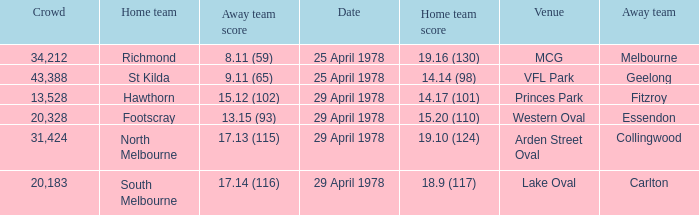What was the away team that played at Princes Park? Fitzroy. Could you parse the entire table? {'header': ['Crowd', 'Home team', 'Away team score', 'Date', 'Home team score', 'Venue', 'Away team'], 'rows': [['34,212', 'Richmond', '8.11 (59)', '25 April 1978', '19.16 (130)', 'MCG', 'Melbourne'], ['43,388', 'St Kilda', '9.11 (65)', '25 April 1978', '14.14 (98)', 'VFL Park', 'Geelong'], ['13,528', 'Hawthorn', '15.12 (102)', '29 April 1978', '14.17 (101)', 'Princes Park', 'Fitzroy'], ['20,328', 'Footscray', '13.15 (93)', '29 April 1978', '15.20 (110)', 'Western Oval', 'Essendon'], ['31,424', 'North Melbourne', '17.13 (115)', '29 April 1978', '19.10 (124)', 'Arden Street Oval', 'Collingwood'], ['20,183', 'South Melbourne', '17.14 (116)', '29 April 1978', '18.9 (117)', 'Lake Oval', 'Carlton']]} 